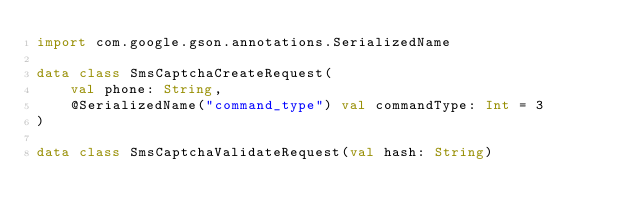Convert code to text. <code><loc_0><loc_0><loc_500><loc_500><_Kotlin_>import com.google.gson.annotations.SerializedName

data class SmsCaptchaCreateRequest(
    val phone: String,
    @SerializedName("command_type") val commandType: Int = 3
)

data class SmsCaptchaValidateRequest(val hash: String)</code> 